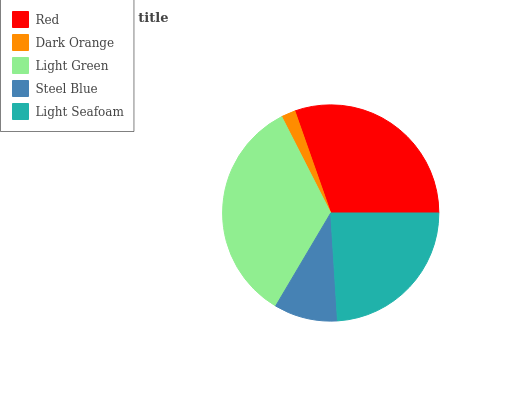Is Dark Orange the minimum?
Answer yes or no. Yes. Is Light Green the maximum?
Answer yes or no. Yes. Is Light Green the minimum?
Answer yes or no. No. Is Dark Orange the maximum?
Answer yes or no. No. Is Light Green greater than Dark Orange?
Answer yes or no. Yes. Is Dark Orange less than Light Green?
Answer yes or no. Yes. Is Dark Orange greater than Light Green?
Answer yes or no. No. Is Light Green less than Dark Orange?
Answer yes or no. No. Is Light Seafoam the high median?
Answer yes or no. Yes. Is Light Seafoam the low median?
Answer yes or no. Yes. Is Light Green the high median?
Answer yes or no. No. Is Red the low median?
Answer yes or no. No. 